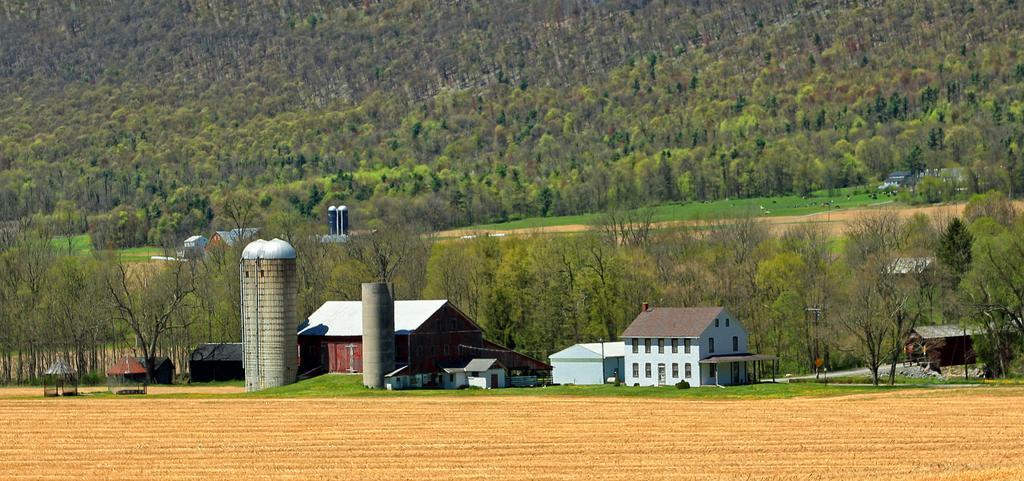How would you summarize this image in a sentence or two? In this image in the front there are houses and in the background there are trees. On the left side in the front there's grass on the ground and there is dry land in the front. 